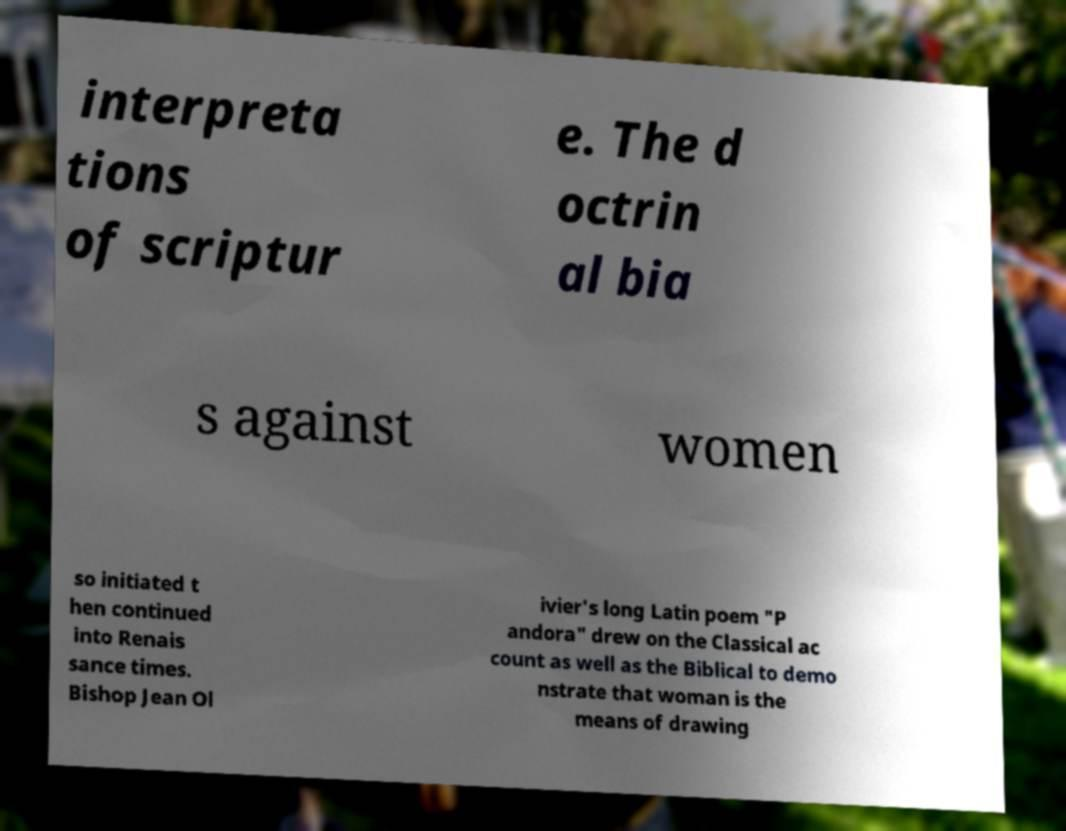What messages or text are displayed in this image? I need them in a readable, typed format. interpreta tions of scriptur e. The d octrin al bia s against women so initiated t hen continued into Renais sance times. Bishop Jean Ol ivier's long Latin poem "P andora" drew on the Classical ac count as well as the Biblical to demo nstrate that woman is the means of drawing 